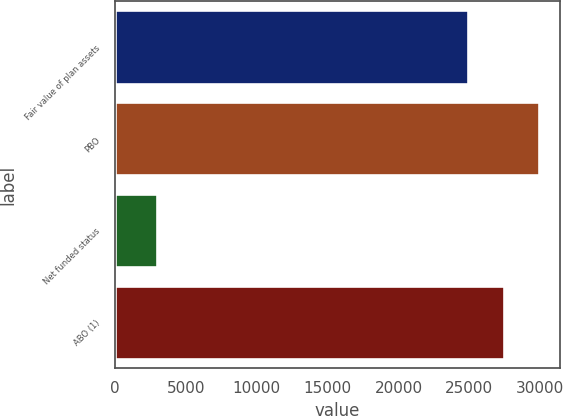<chart> <loc_0><loc_0><loc_500><loc_500><bar_chart><fcel>Fair value of plan assets<fcel>PBO<fcel>Net funded status<fcel>ABO (1)<nl><fcel>24933<fcel>29919.6<fcel>2937<fcel>27426.3<nl></chart> 